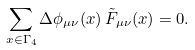Convert formula to latex. <formula><loc_0><loc_0><loc_500><loc_500>\sum _ { x \in \Gamma _ { 4 } } \Delta \phi _ { \mu \nu } ( x ) \, \tilde { F } _ { \mu \nu } ( x ) = 0 .</formula> 